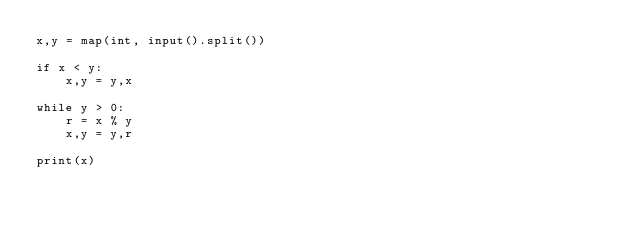Convert code to text. <code><loc_0><loc_0><loc_500><loc_500><_Python_>x,y = map(int, input().split())

if x < y:
    x,y = y,x

while y > 0:
    r = x % y
    x,y = y,r
    
print(x)
</code> 